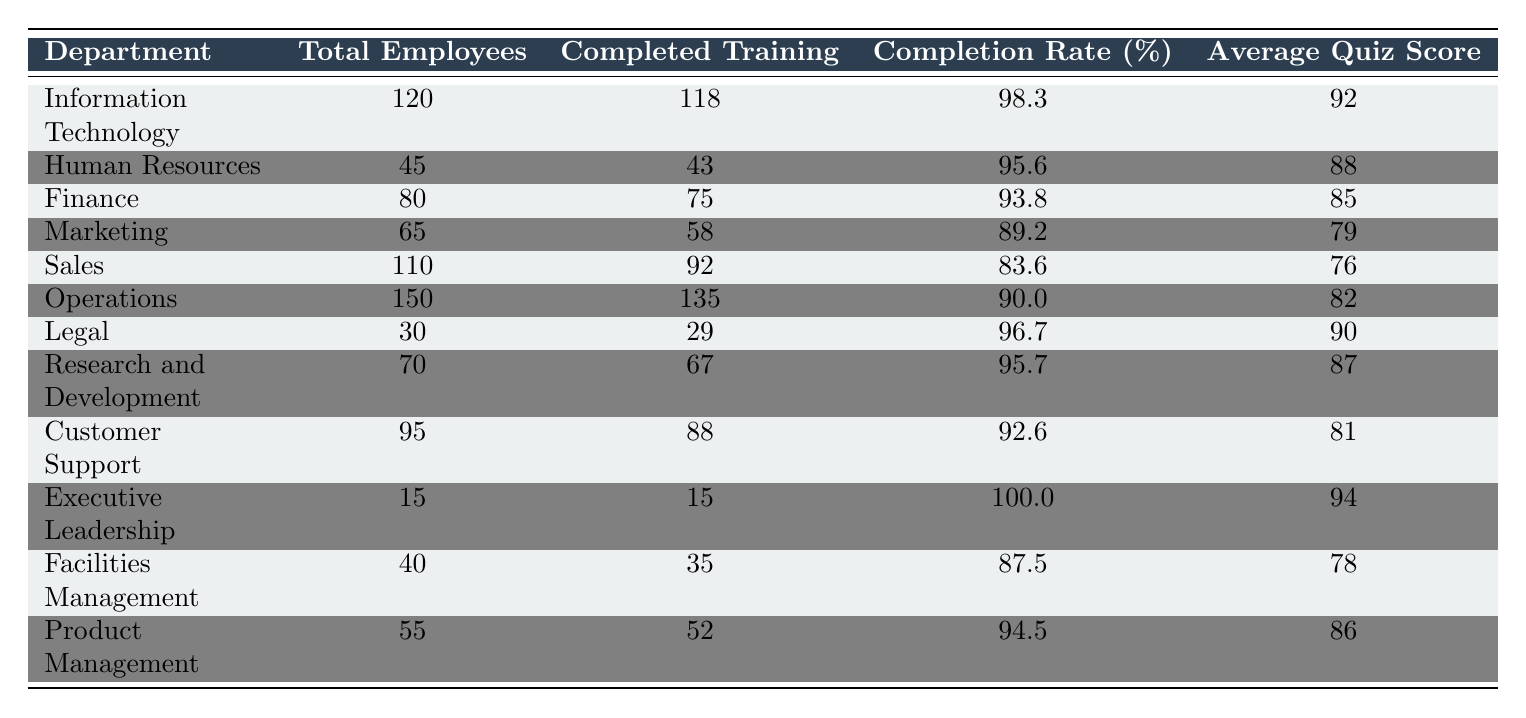What is the completion rate for the Human Resources department? The completion rate for Human Resources is directly listed in the table as 95.6%.
Answer: 95.6% Which department had the highest average quiz score? The department with the highest average quiz score is Information Technology, with a score of 92.
Answer: 92 What is the total number of employees in the Sales department? The total number of employees in the Sales department is stated in the table as 110.
Answer: 110 What is the average quiz score for the Legal department? The average quiz score for the Legal department is provided in the table as 90.
Answer: 90 How many employees in the Finance department completed the training? The table indicates that 75 employees in the Finance department completed the training.
Answer: 75 What is the difference in completion rates between the Operations and Marketing departments? The completion rate for Operations is 90.0% and for Marketing is 89.2%. The difference is 90.0 - 89.2 = 0.8%.
Answer: 0.8% Are there more total employees in the IT department than in the Customer Support department? Yes, the table shows that IT has 120 employees and Customer Support has 95 employees, so IT has more.
Answer: Yes What is the average completion rate across all departments? To calculate the average, sum the completion rates of all departments: (98.3 + 95.6 + 93.8 + 89.2 + 83.6 + 90.0 + 96.7 + 95.7 + 92.6 + 100.0 + 87.5 + 94.5) = 1151.4, then divide by 12, giving an average of approximately 95.95%.
Answer: 95.95% Which department had a lower completion rate: Facilities Management or Marketing? Facilities Management has a completion rate of 87.5%, while Marketing has 89.2%. Since 87.5% is less than 89.2%, Facilities Management had a lower rate.
Answer: Facilities Management How many more employees completed training in the Operations department compared to the Marketing department? The Operations department had 135 completions while Marketing had 58, thus 135 - 58 = 77 more employees completed the training in Operations.
Answer: 77 